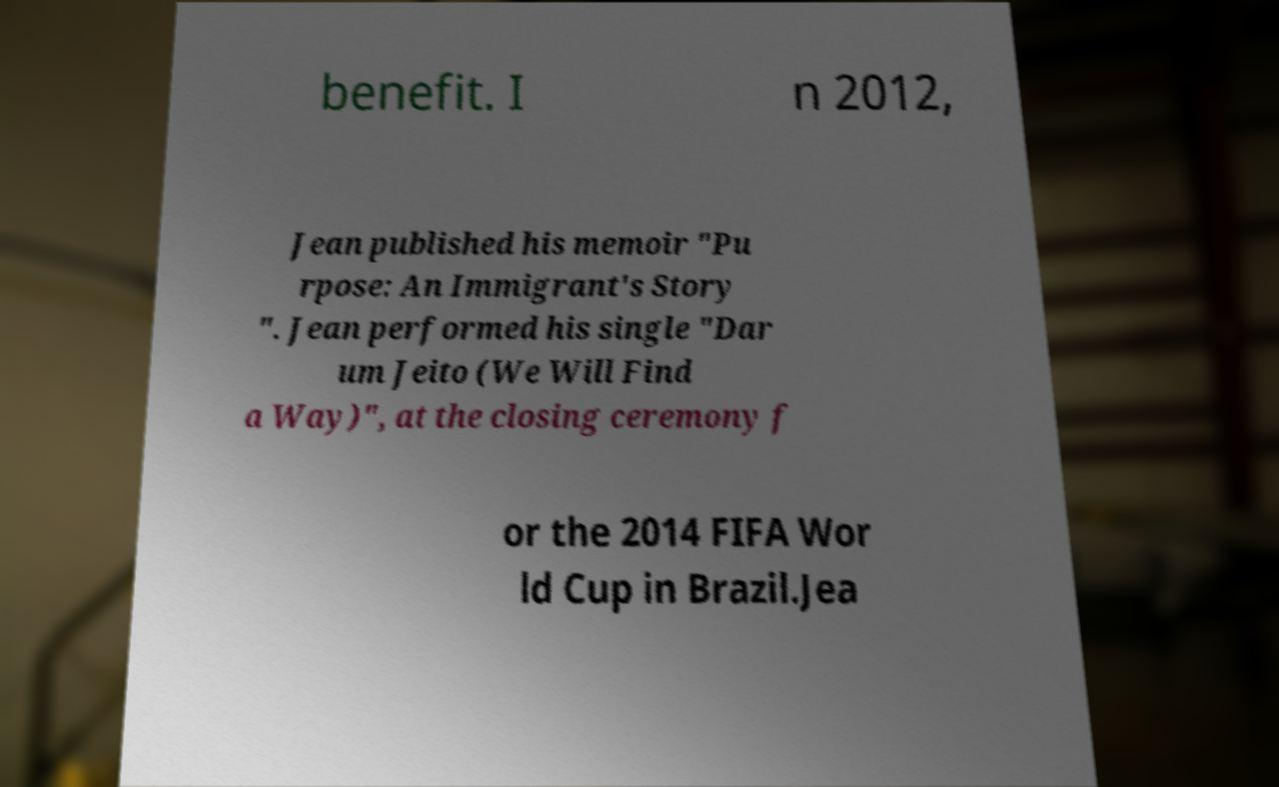Please read and relay the text visible in this image. What does it say? benefit. I n 2012, Jean published his memoir "Pu rpose: An Immigrant's Story ". Jean performed his single "Dar um Jeito (We Will Find a Way)", at the closing ceremony f or the 2014 FIFA Wor ld Cup in Brazil.Jea 